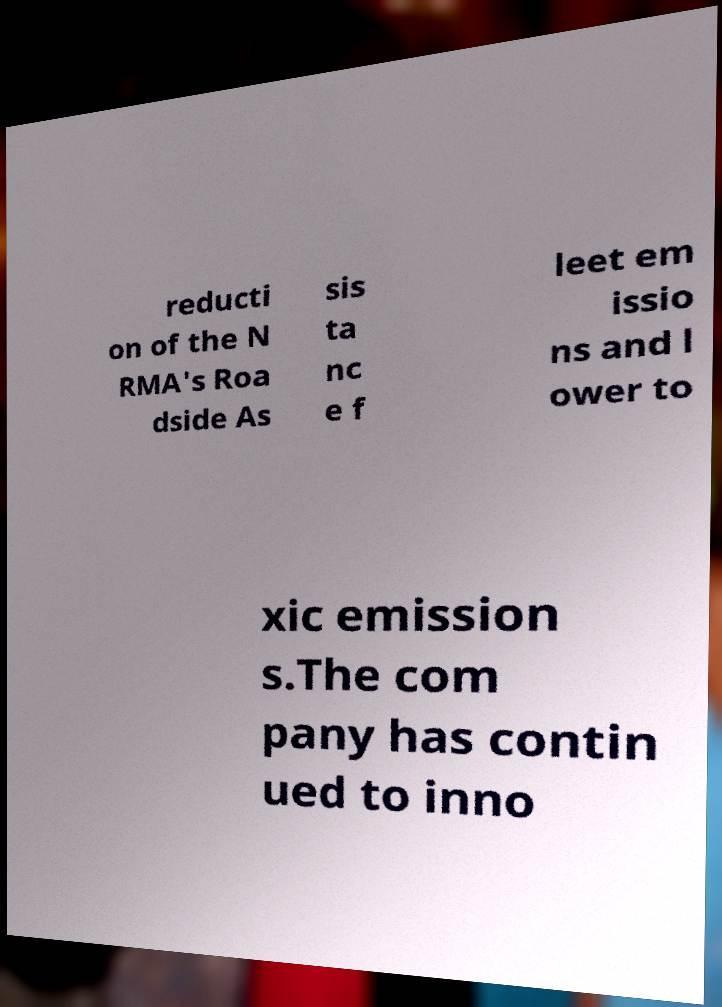There's text embedded in this image that I need extracted. Can you transcribe it verbatim? reducti on of the N RMA's Roa dside As sis ta nc e f leet em issio ns and l ower to xic emission s.The com pany has contin ued to inno 